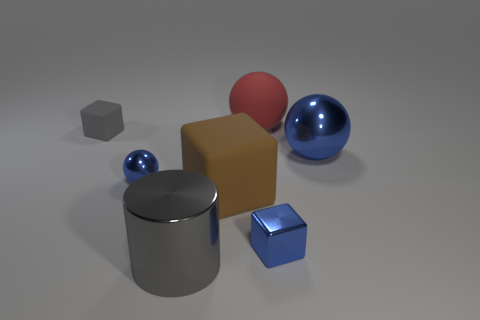There is a brown object that is the same size as the gray shiny cylinder; what is its material?
Provide a succinct answer. Rubber. There is a big ball that is behind the small gray matte block; what is its color?
Offer a terse response. Red. What number of red spheres are there?
Make the answer very short. 1. There is a metallic object that is in front of the small cube that is in front of the tiny gray cube; are there any rubber cubes left of it?
Provide a short and direct response. Yes. There is a blue metallic thing that is the same size as the brown matte object; what shape is it?
Provide a short and direct response. Sphere. How many other things are there of the same color as the metallic cube?
Ensure brevity in your answer.  2. What material is the red object?
Your response must be concise. Rubber. What number of other objects are the same material as the large gray cylinder?
Your response must be concise. 3. What size is the thing that is in front of the gray matte block and to the left of the gray metal object?
Offer a very short reply. Small. What shape is the large object that is behind the blue metal sphere to the right of the small blue ball?
Provide a short and direct response. Sphere. 